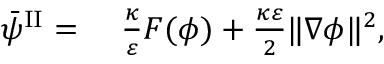Convert formula to latex. <formula><loc_0><loc_0><loc_500><loc_500>\begin{array} { r l } { \bar { \psi } ^ { I I } = } & \frac { \kappa } { \varepsilon } F ( \phi ) + \frac { \kappa \varepsilon } { 2 } \| \nabla \phi \| ^ { 2 } , } \end{array}</formula> 